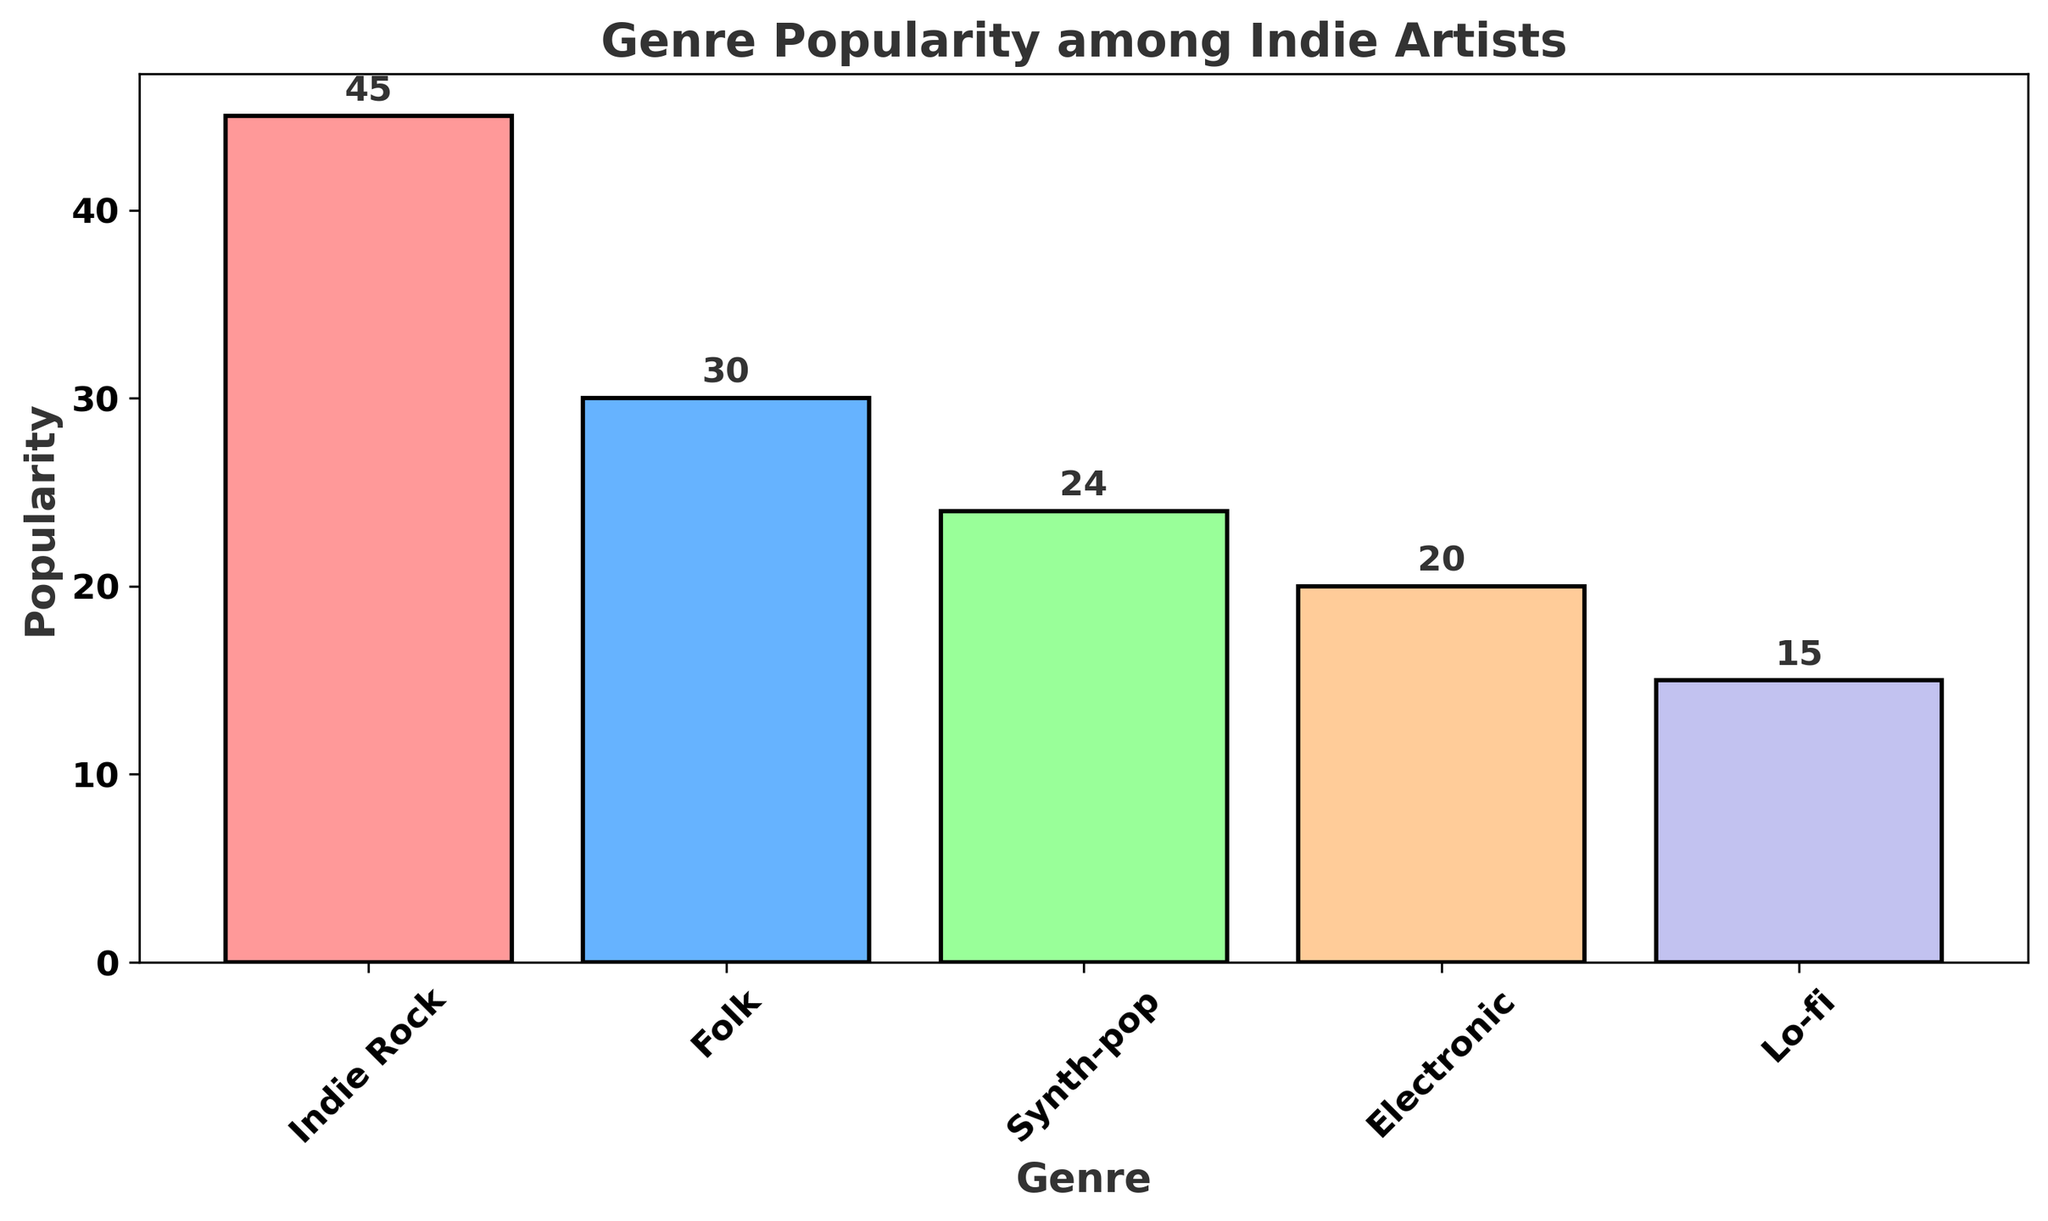what is the most popular genre among indie artists? The figure shows the heights of the bars for different genres. The tallest bar corresponds to Indie Rock, indicating it has the highest popularity.
Answer: Indie Rock What is the combined popularity of Folk and Lo-fi genres? The figure shows that Folk has a popularity of 30 and Lo-fi has a popularity of 15. Adding these values together gives 30 + 15 = 45.
Answer: 45 Which genre is less popular, Synth-pop or Electronic? By comparing the heights of the bars for Synth-pop and Electronic, Synth-pop has a height of 24 and Electronic has a height of 20. Hence, Electronic is less popular.
Answer: Electronic What is the average popularity of all the genres combined? Added all the popularity values together: 45 (Indie Rock) + 30 (Folk) + 24 (Synth-pop) + 20 (Electronic) + 15 (Lo-fi) = 134. Dividing this by the number of genres (5) gives an average of 134/5 = 26.8.
Answer: 26.8 What is the difference in popularity between the most and least popular genres? The most popular genre is Indie Rock with a popularity of 45, and the least popular is Lo-fi with a popularity of 15. The difference is 45 - 15 = 30.
Answer: 30 Which genre comes third in terms of popularity? By visually inspecting the bars, the third highest bar after Indie Rock (45) and Folk (30) is Synth-pop with a height of 24.
Answer: Synth-pop How many genres have a popularity higher than 20? Counting the bars with heights greater than 20 reveals that Indie Rock (45), Folk (30), and Synth-pop (24) all exceed 20. Hence, there are 3 genres.
Answer: 3 What color represents the Electronic genre in the chart? Checking the color of the bar labeled "Electronic" reveals it to be peach.
Answer: Peach Is the popularity of Indie Rock more than double that of Lo-fi? Indie Rock has a popularity of 45, and Lo-fi has 15. Checking if 45 is more than double of 15 (which is 30) shows that it is indeed more than double.
Answer: Yes What is the median popularity value among the genres? Ordering the popularity values (15, 20, 24, 30, 45) and finding the middle value shows that the median value is 24, corresponding to Synth-pop.
Answer: 24 